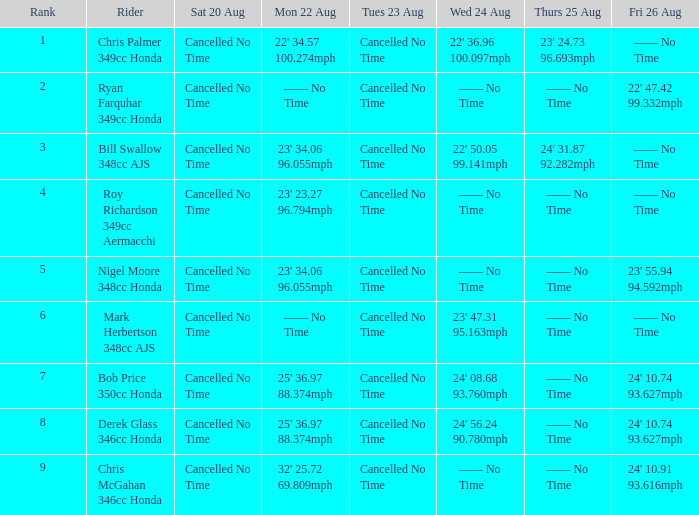What is every entry on Monday August 22 when the entry for Wednesday August 24 is 22' 50.05 99.141mph? 23' 34.06 96.055mph. 